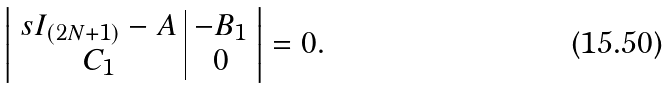Convert formula to latex. <formula><loc_0><loc_0><loc_500><loc_500>\left | \begin{array} { c | c } s I _ { ( 2 N + 1 ) } - A & - B _ { 1 } \\ C _ { 1 } & 0 \end{array} \right | = 0 .</formula> 